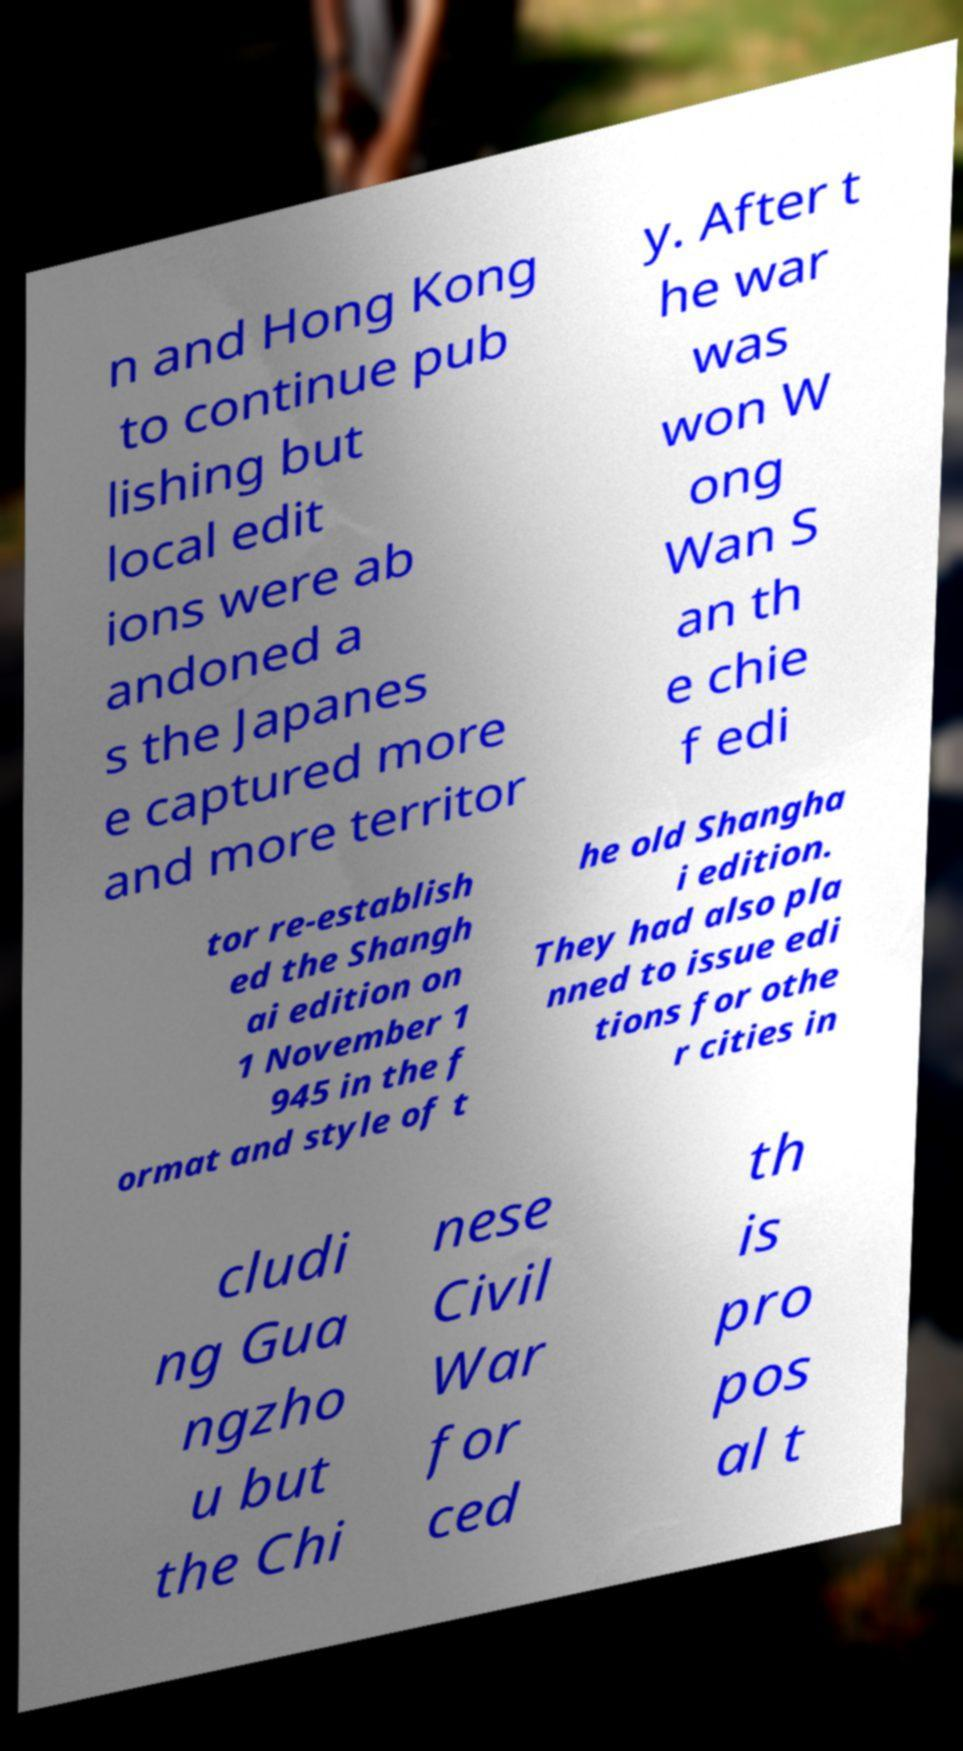For documentation purposes, I need the text within this image transcribed. Could you provide that? n and Hong Kong to continue pub lishing but local edit ions were ab andoned a s the Japanes e captured more and more territor y. After t he war was won W ong Wan S an th e chie f edi tor re-establish ed the Shangh ai edition on 1 November 1 945 in the f ormat and style of t he old Shangha i edition. They had also pla nned to issue edi tions for othe r cities in cludi ng Gua ngzho u but the Chi nese Civil War for ced th is pro pos al t 